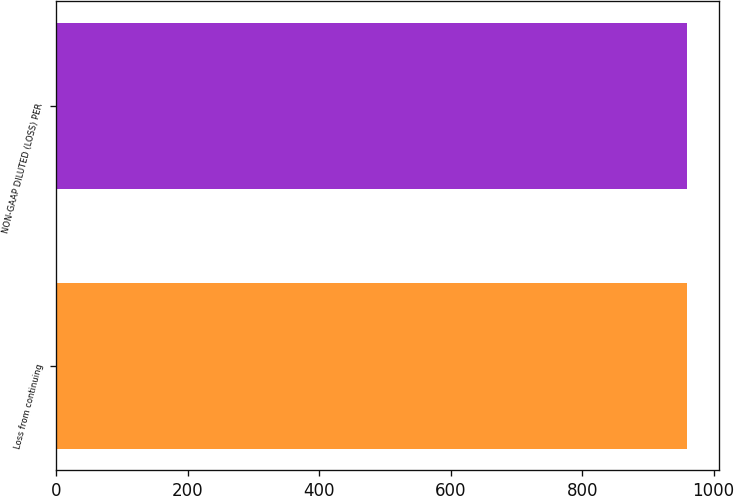<chart> <loc_0><loc_0><loc_500><loc_500><bar_chart><fcel>Loss from continuing<fcel>NON-GAAP DILUTED (LOSS) PER<nl><fcel>960<fcel>960.1<nl></chart> 